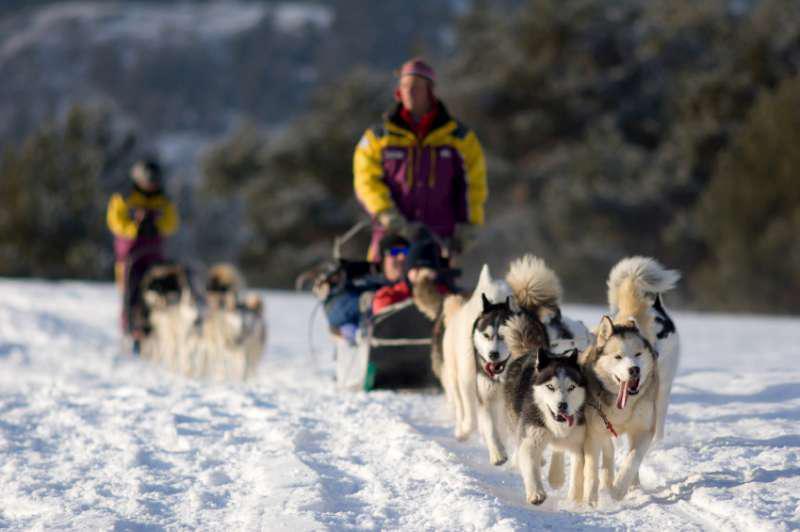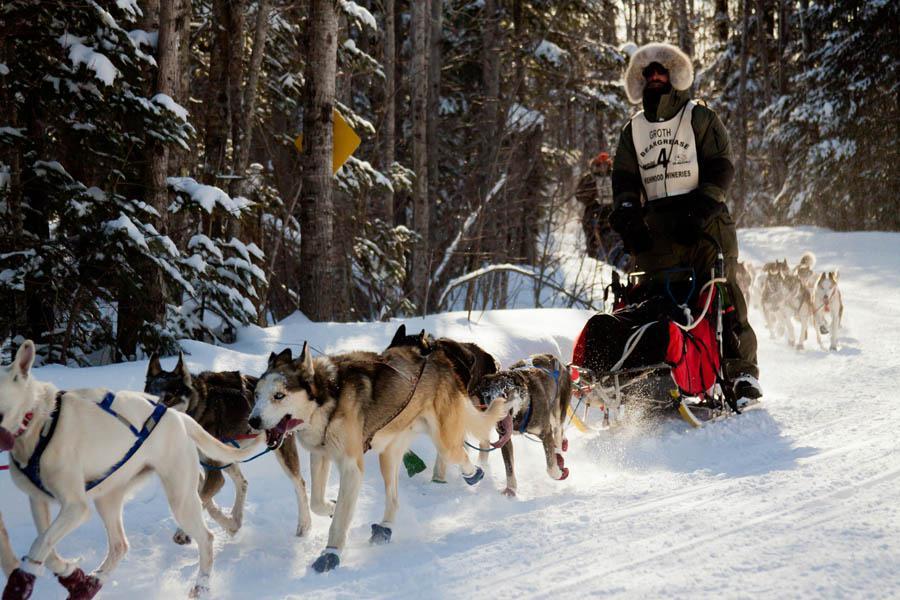The first image is the image on the left, the second image is the image on the right. Given the left and right images, does the statement "Two or fewer humans are visible." hold true? Answer yes or no. No. The first image is the image on the left, the second image is the image on the right. For the images displayed, is the sentence "At least one of the drivers is wearing yellow." factually correct? Answer yes or no. Yes. 